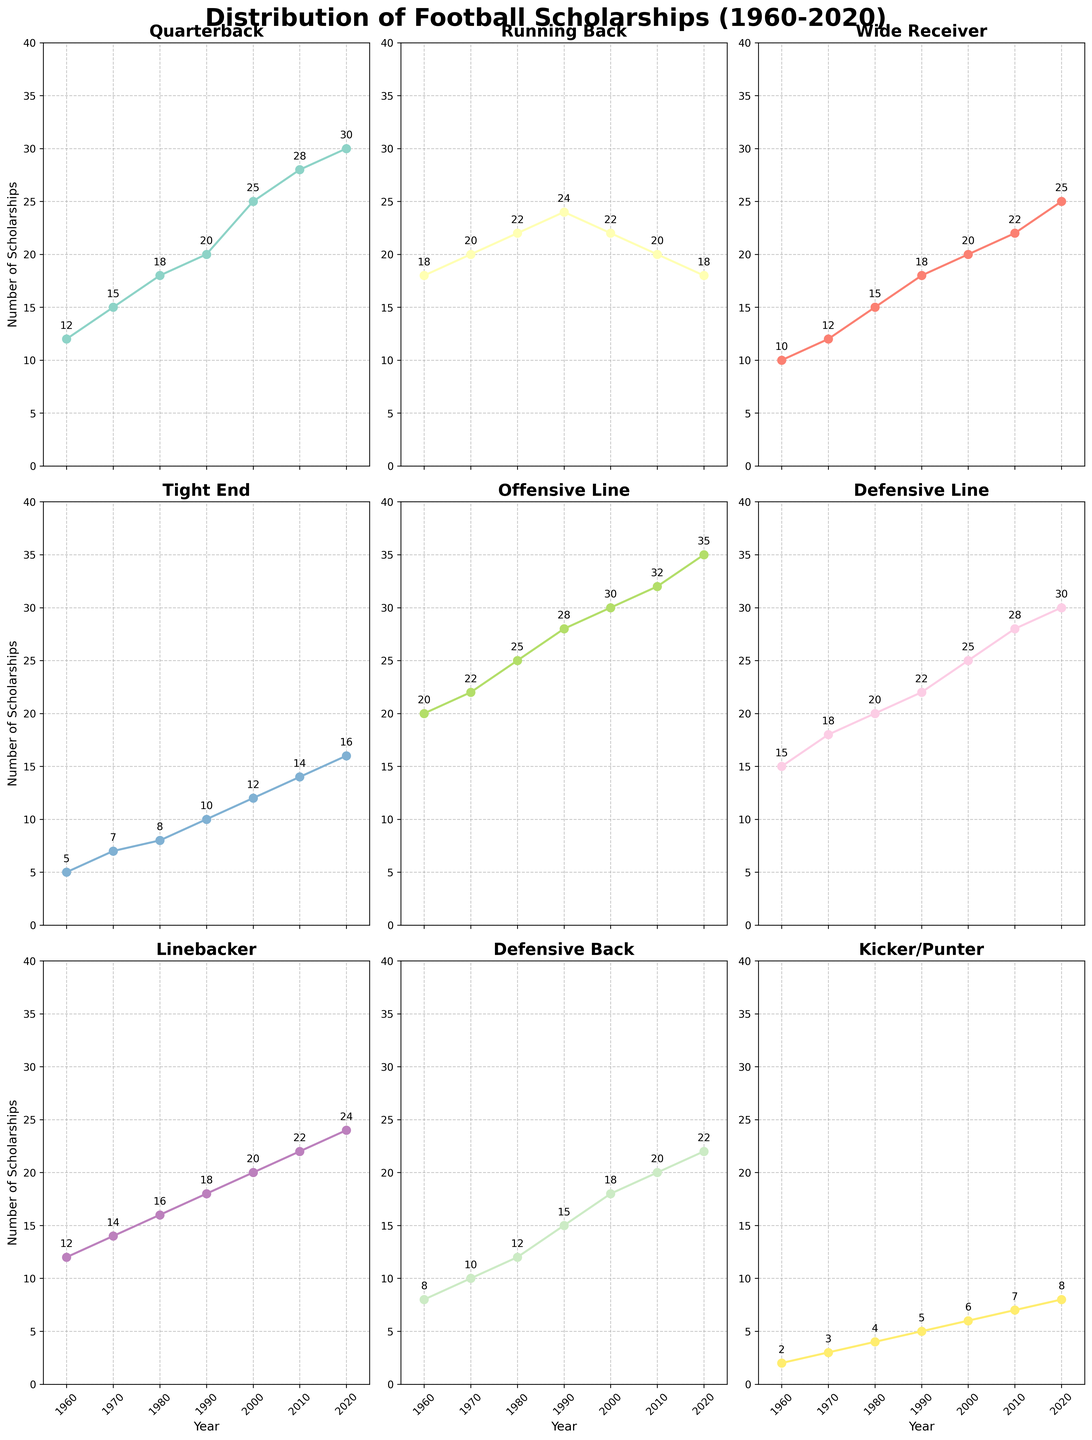What's the title of the figure? The title is located at the top center of the figure and is usually in a larger, bold font indicating the main focus of the plot. In this case, it reads: "Distribution of Football Scholarships (1960-2020)".
Answer: Distribution of Football Scholarships (1960-2020) How many positional subplots are there in the figure? By counting the individual subplots, there are 9 subplots corresponding to each football position.
Answer: 9 Which position had the most significant increase in scholarships from 1960 to 2020? By looking at the starting and ending values for each position, Offensive Line started at 20 scholarships in 1960 and increased to 35 scholarships in 2020. This is a significant increase of 15 scholarships.
Answer: Offensive Line In what year did Running Backs see a peak in the number of scholarships awarded? Observing the trend line for Running Backs across the years, it peaked in 1990 with 24 scholarships.
Answer: 1990 What's the difference in the number of scholarships awarded to Quarterbacks between 1960 and 2020? In 1960, 12 scholarships were awarded to Quarterbacks, and this increased to 30 by 2020. The difference is 30 - 12 = 18.
Answer: 18 Between which years did Kickers/Punters see the largest relative increase in scholarships? By analyzing the slope of the line for Kickers/Punters, the largest relative increase was between 1960 (2) and 1970 (3), which is a 50% increase (1 scholarship).
Answer: 1960-1970 Which position had the most stable distribution of scholarships between 1960 and 2020? Tight Ends went from 5 scholarships in 1960 to 16 in 2020, indicating more stability with the least rapid changes.
Answer: Tight End How does the number of scholarships for Wide Receivers in 2000 compare to that in 2020? The number of scholarships for Wide Receivers in 2000 was 20, and it increased to 25 in 2020, showing an increase of 5 scholarships.
Answer: Increased by 5 Are there any subplots where the number of scholarships awarded decreased over the years? No positional subplot shows a consistent decrease over the years; most show an increase or stabilization.
Answer: No What is the overall trend in the number of football scholarships awarded from 1960 to 2020 across all positions? Each subplot's trend line generally shows an upward trajectory, suggesting an overall increase in football scholarships awarded over the given period.
Answer: Increasing 